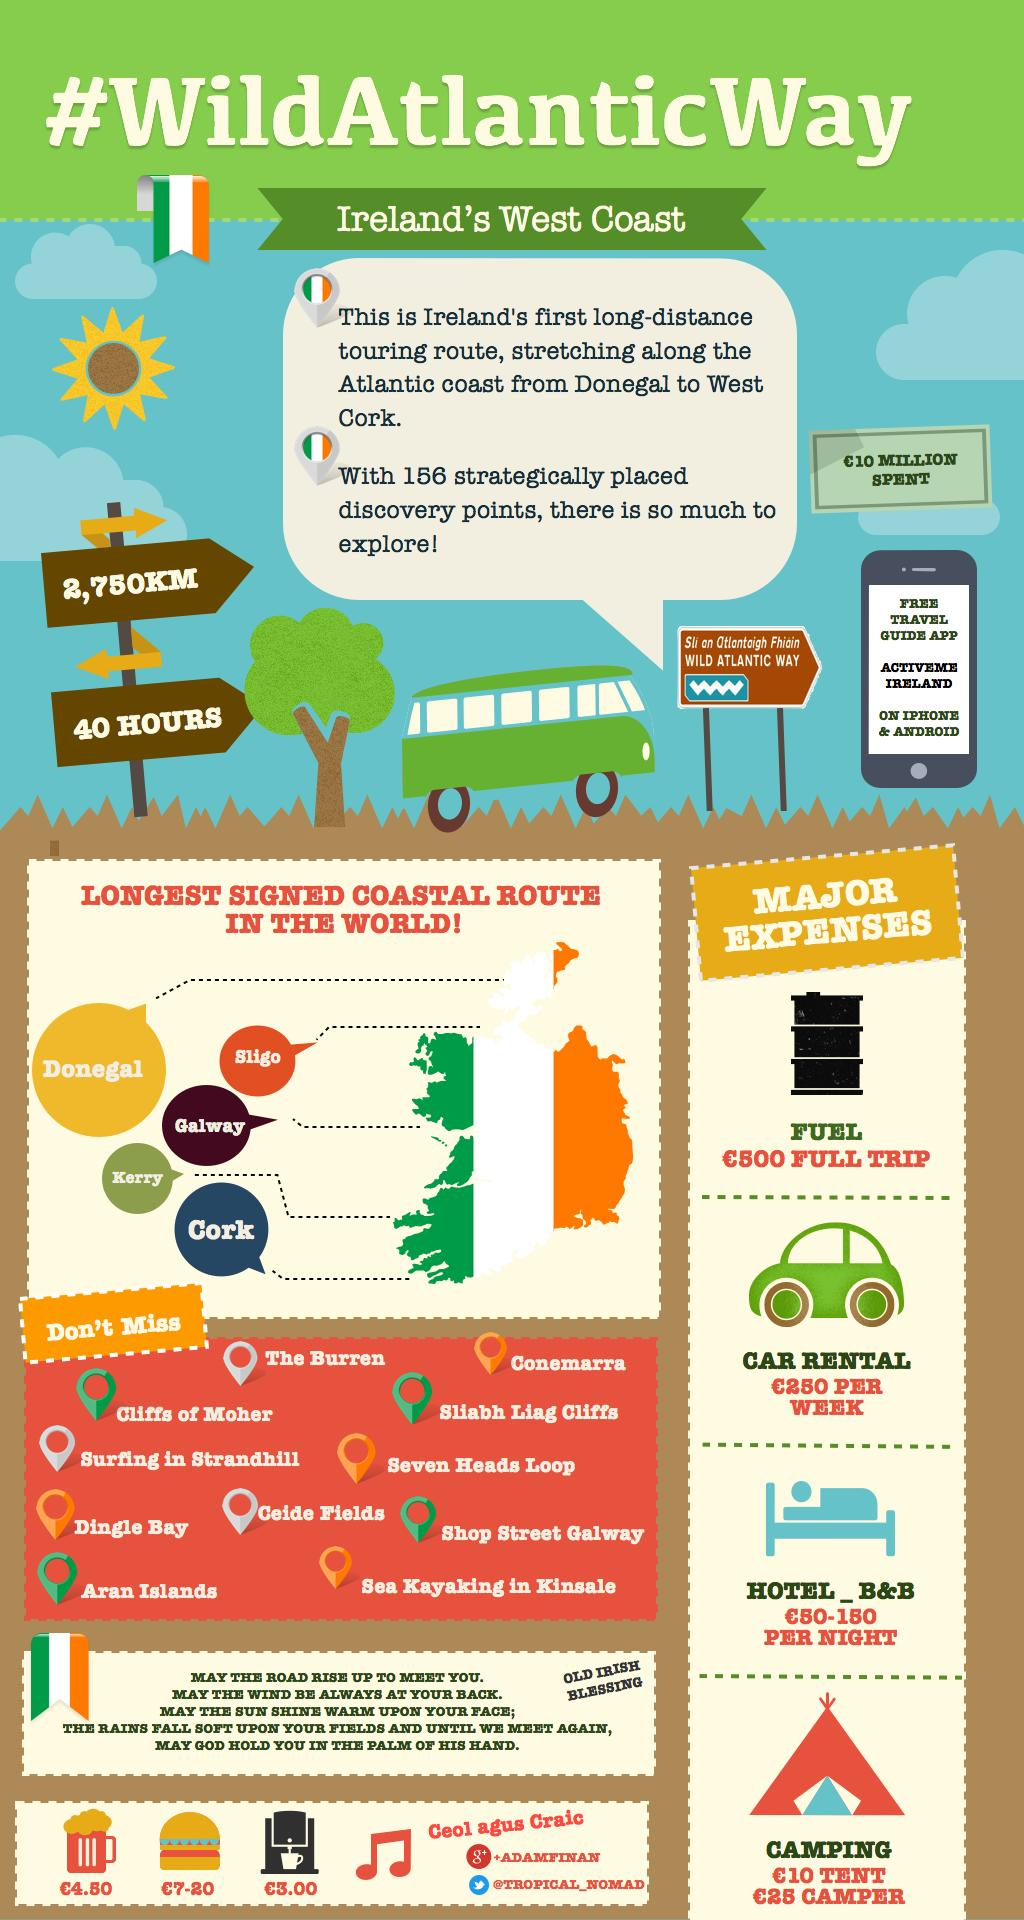Give some essential details in this illustration. Four major expenses need to be addressed. The estimated time for this route is 40 hours. The touring route is 2,750 kilometers in length. 